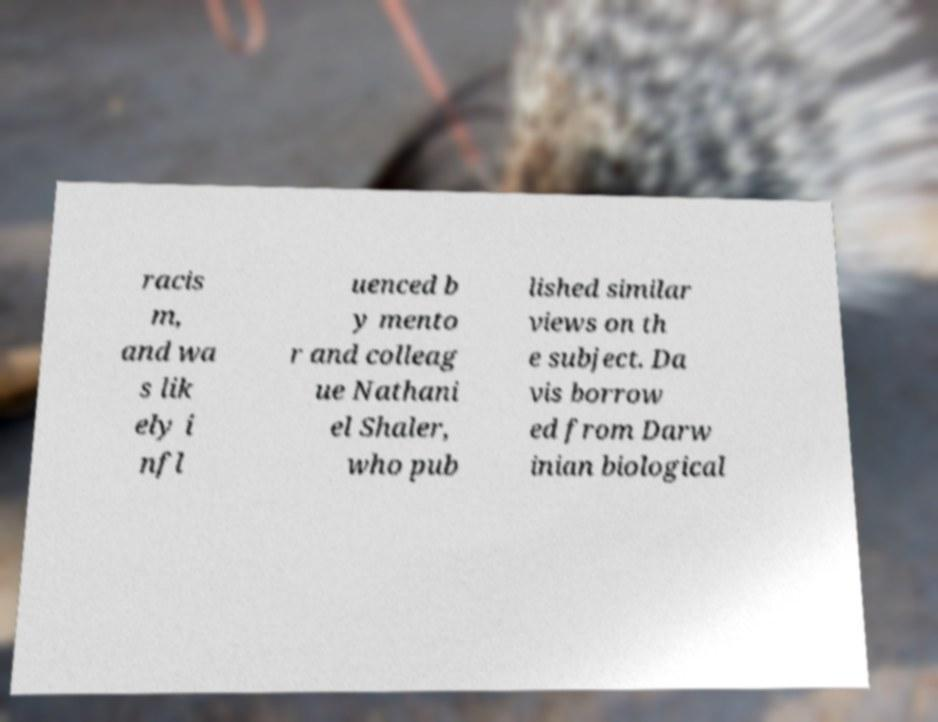Please read and relay the text visible in this image. What does it say? racis m, and wa s lik ely i nfl uenced b y mento r and colleag ue Nathani el Shaler, who pub lished similar views on th e subject. Da vis borrow ed from Darw inian biological 